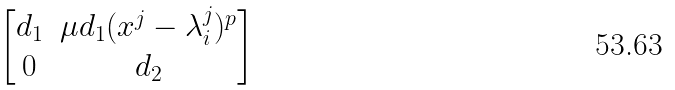Convert formula to latex. <formula><loc_0><loc_0><loc_500><loc_500>\begin{bmatrix} d _ { 1 } & \mu d _ { 1 } ( x ^ { j } - \lambda _ { i } ^ { j } ) ^ { p } \\ 0 & d _ { 2 } \end{bmatrix}</formula> 